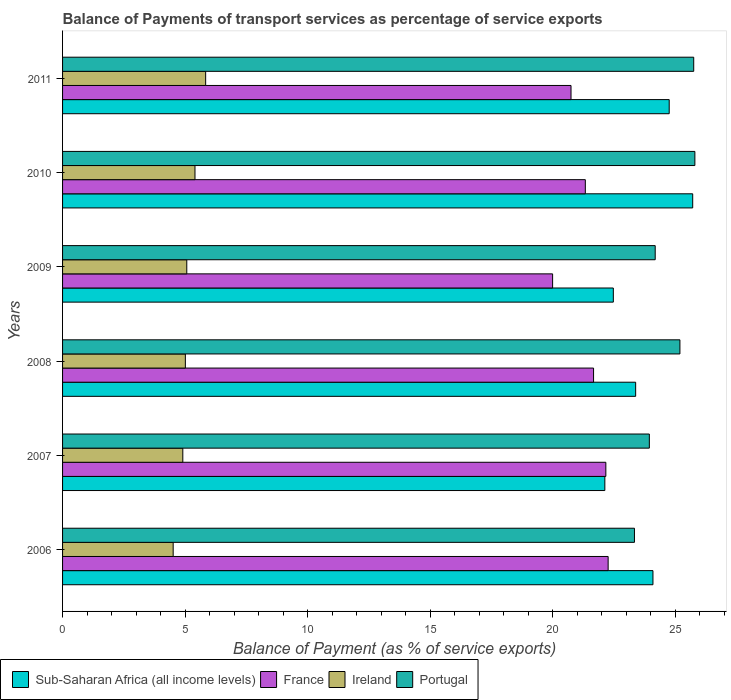How many groups of bars are there?
Keep it short and to the point. 6. Are the number of bars on each tick of the Y-axis equal?
Offer a very short reply. Yes. How many bars are there on the 3rd tick from the top?
Give a very brief answer. 4. How many bars are there on the 1st tick from the bottom?
Keep it short and to the point. 4. What is the label of the 6th group of bars from the top?
Provide a short and direct response. 2006. In how many cases, is the number of bars for a given year not equal to the number of legend labels?
Your answer should be compact. 0. What is the balance of payments of transport services in France in 2006?
Offer a terse response. 22.27. Across all years, what is the maximum balance of payments of transport services in Ireland?
Ensure brevity in your answer.  5.84. Across all years, what is the minimum balance of payments of transport services in France?
Provide a short and direct response. 20. In which year was the balance of payments of transport services in Portugal minimum?
Provide a short and direct response. 2006. What is the total balance of payments of transport services in Portugal in the graph?
Provide a short and direct response. 148.26. What is the difference between the balance of payments of transport services in Ireland in 2007 and that in 2010?
Offer a very short reply. -0.5. What is the difference between the balance of payments of transport services in Sub-Saharan Africa (all income levels) in 2011 and the balance of payments of transport services in Portugal in 2007?
Provide a succinct answer. 0.81. What is the average balance of payments of transport services in Portugal per year?
Ensure brevity in your answer.  24.71. In the year 2007, what is the difference between the balance of payments of transport services in Ireland and balance of payments of transport services in France?
Provide a short and direct response. -17.27. In how many years, is the balance of payments of transport services in Sub-Saharan Africa (all income levels) greater than 1 %?
Give a very brief answer. 6. What is the ratio of the balance of payments of transport services in Sub-Saharan Africa (all income levels) in 2006 to that in 2009?
Your answer should be very brief. 1.07. Is the balance of payments of transport services in Portugal in 2006 less than that in 2011?
Provide a short and direct response. Yes. Is the difference between the balance of payments of transport services in Ireland in 2006 and 2010 greater than the difference between the balance of payments of transport services in France in 2006 and 2010?
Ensure brevity in your answer.  No. What is the difference between the highest and the second highest balance of payments of transport services in Ireland?
Offer a terse response. 0.44. What is the difference between the highest and the lowest balance of payments of transport services in Portugal?
Keep it short and to the point. 2.47. What does the 1st bar from the bottom in 2007 represents?
Provide a succinct answer. Sub-Saharan Africa (all income levels). How many bars are there?
Offer a very short reply. 24. Are all the bars in the graph horizontal?
Offer a very short reply. Yes. What is the difference between two consecutive major ticks on the X-axis?
Your answer should be compact. 5. Are the values on the major ticks of X-axis written in scientific E-notation?
Your answer should be very brief. No. Does the graph contain any zero values?
Keep it short and to the point. No. Does the graph contain grids?
Provide a short and direct response. No. Where does the legend appear in the graph?
Keep it short and to the point. Bottom left. How are the legend labels stacked?
Offer a terse response. Horizontal. What is the title of the graph?
Provide a succinct answer. Balance of Payments of transport services as percentage of service exports. What is the label or title of the X-axis?
Your answer should be compact. Balance of Payment (as % of service exports). What is the label or title of the Y-axis?
Keep it short and to the point. Years. What is the Balance of Payment (as % of service exports) of Sub-Saharan Africa (all income levels) in 2006?
Provide a succinct answer. 24.1. What is the Balance of Payment (as % of service exports) in France in 2006?
Provide a succinct answer. 22.27. What is the Balance of Payment (as % of service exports) of Ireland in 2006?
Offer a very short reply. 4.52. What is the Balance of Payment (as % of service exports) of Portugal in 2006?
Your answer should be very brief. 23.34. What is the Balance of Payment (as % of service exports) of Sub-Saharan Africa (all income levels) in 2007?
Your answer should be very brief. 22.14. What is the Balance of Payment (as % of service exports) in France in 2007?
Offer a terse response. 22.18. What is the Balance of Payment (as % of service exports) in Ireland in 2007?
Your answer should be very brief. 4.91. What is the Balance of Payment (as % of service exports) of Portugal in 2007?
Offer a terse response. 23.95. What is the Balance of Payment (as % of service exports) of Sub-Saharan Africa (all income levels) in 2008?
Your answer should be compact. 23.39. What is the Balance of Payment (as % of service exports) in France in 2008?
Provide a short and direct response. 21.67. What is the Balance of Payment (as % of service exports) of Ireland in 2008?
Keep it short and to the point. 5.01. What is the Balance of Payment (as % of service exports) in Portugal in 2008?
Keep it short and to the point. 25.2. What is the Balance of Payment (as % of service exports) in Sub-Saharan Africa (all income levels) in 2009?
Offer a terse response. 22.48. What is the Balance of Payment (as % of service exports) in France in 2009?
Make the answer very short. 20. What is the Balance of Payment (as % of service exports) of Ireland in 2009?
Give a very brief answer. 5.07. What is the Balance of Payment (as % of service exports) of Portugal in 2009?
Provide a succinct answer. 24.19. What is the Balance of Payment (as % of service exports) in Sub-Saharan Africa (all income levels) in 2010?
Offer a very short reply. 25.72. What is the Balance of Payment (as % of service exports) in France in 2010?
Offer a terse response. 21.34. What is the Balance of Payment (as % of service exports) in Ireland in 2010?
Give a very brief answer. 5.4. What is the Balance of Payment (as % of service exports) of Portugal in 2010?
Your answer should be very brief. 25.81. What is the Balance of Payment (as % of service exports) in Sub-Saharan Africa (all income levels) in 2011?
Your response must be concise. 24.76. What is the Balance of Payment (as % of service exports) of France in 2011?
Keep it short and to the point. 20.75. What is the Balance of Payment (as % of service exports) in Ireland in 2011?
Ensure brevity in your answer.  5.84. What is the Balance of Payment (as % of service exports) in Portugal in 2011?
Ensure brevity in your answer.  25.76. Across all years, what is the maximum Balance of Payment (as % of service exports) in Sub-Saharan Africa (all income levels)?
Your answer should be compact. 25.72. Across all years, what is the maximum Balance of Payment (as % of service exports) in France?
Keep it short and to the point. 22.27. Across all years, what is the maximum Balance of Payment (as % of service exports) of Ireland?
Your answer should be very brief. 5.84. Across all years, what is the maximum Balance of Payment (as % of service exports) in Portugal?
Your response must be concise. 25.81. Across all years, what is the minimum Balance of Payment (as % of service exports) of Sub-Saharan Africa (all income levels)?
Your response must be concise. 22.14. Across all years, what is the minimum Balance of Payment (as % of service exports) of France?
Provide a short and direct response. 20. Across all years, what is the minimum Balance of Payment (as % of service exports) in Ireland?
Offer a terse response. 4.52. Across all years, what is the minimum Balance of Payment (as % of service exports) of Portugal?
Provide a short and direct response. 23.34. What is the total Balance of Payment (as % of service exports) in Sub-Saharan Africa (all income levels) in the graph?
Provide a short and direct response. 142.59. What is the total Balance of Payment (as % of service exports) of France in the graph?
Your response must be concise. 128.22. What is the total Balance of Payment (as % of service exports) of Ireland in the graph?
Provide a short and direct response. 30.75. What is the total Balance of Payment (as % of service exports) in Portugal in the graph?
Your answer should be very brief. 148.26. What is the difference between the Balance of Payment (as % of service exports) of Sub-Saharan Africa (all income levels) in 2006 and that in 2007?
Ensure brevity in your answer.  1.96. What is the difference between the Balance of Payment (as % of service exports) in France in 2006 and that in 2007?
Offer a very short reply. 0.09. What is the difference between the Balance of Payment (as % of service exports) in Ireland in 2006 and that in 2007?
Your response must be concise. -0.39. What is the difference between the Balance of Payment (as % of service exports) of Portugal in 2006 and that in 2007?
Offer a very short reply. -0.61. What is the difference between the Balance of Payment (as % of service exports) in Sub-Saharan Africa (all income levels) in 2006 and that in 2008?
Offer a very short reply. 0.71. What is the difference between the Balance of Payment (as % of service exports) of France in 2006 and that in 2008?
Offer a terse response. 0.6. What is the difference between the Balance of Payment (as % of service exports) in Ireland in 2006 and that in 2008?
Make the answer very short. -0.5. What is the difference between the Balance of Payment (as % of service exports) of Portugal in 2006 and that in 2008?
Give a very brief answer. -1.86. What is the difference between the Balance of Payment (as % of service exports) in Sub-Saharan Africa (all income levels) in 2006 and that in 2009?
Offer a terse response. 1.62. What is the difference between the Balance of Payment (as % of service exports) of France in 2006 and that in 2009?
Provide a succinct answer. 2.27. What is the difference between the Balance of Payment (as % of service exports) in Ireland in 2006 and that in 2009?
Ensure brevity in your answer.  -0.56. What is the difference between the Balance of Payment (as % of service exports) in Portugal in 2006 and that in 2009?
Your response must be concise. -0.85. What is the difference between the Balance of Payment (as % of service exports) of Sub-Saharan Africa (all income levels) in 2006 and that in 2010?
Keep it short and to the point. -1.62. What is the difference between the Balance of Payment (as % of service exports) in France in 2006 and that in 2010?
Your answer should be very brief. 0.93. What is the difference between the Balance of Payment (as % of service exports) of Ireland in 2006 and that in 2010?
Your answer should be very brief. -0.89. What is the difference between the Balance of Payment (as % of service exports) in Portugal in 2006 and that in 2010?
Keep it short and to the point. -2.47. What is the difference between the Balance of Payment (as % of service exports) of Sub-Saharan Africa (all income levels) in 2006 and that in 2011?
Ensure brevity in your answer.  -0.66. What is the difference between the Balance of Payment (as % of service exports) of France in 2006 and that in 2011?
Offer a terse response. 1.52. What is the difference between the Balance of Payment (as % of service exports) of Ireland in 2006 and that in 2011?
Offer a terse response. -1.33. What is the difference between the Balance of Payment (as % of service exports) in Portugal in 2006 and that in 2011?
Make the answer very short. -2.42. What is the difference between the Balance of Payment (as % of service exports) of Sub-Saharan Africa (all income levels) in 2007 and that in 2008?
Your response must be concise. -1.26. What is the difference between the Balance of Payment (as % of service exports) in France in 2007 and that in 2008?
Ensure brevity in your answer.  0.5. What is the difference between the Balance of Payment (as % of service exports) of Ireland in 2007 and that in 2008?
Provide a succinct answer. -0.1. What is the difference between the Balance of Payment (as % of service exports) of Portugal in 2007 and that in 2008?
Give a very brief answer. -1.25. What is the difference between the Balance of Payment (as % of service exports) in Sub-Saharan Africa (all income levels) in 2007 and that in 2009?
Offer a terse response. -0.35. What is the difference between the Balance of Payment (as % of service exports) of France in 2007 and that in 2009?
Your answer should be compact. 2.17. What is the difference between the Balance of Payment (as % of service exports) in Ireland in 2007 and that in 2009?
Provide a short and direct response. -0.16. What is the difference between the Balance of Payment (as % of service exports) in Portugal in 2007 and that in 2009?
Provide a short and direct response. -0.24. What is the difference between the Balance of Payment (as % of service exports) of Sub-Saharan Africa (all income levels) in 2007 and that in 2010?
Keep it short and to the point. -3.59. What is the difference between the Balance of Payment (as % of service exports) in France in 2007 and that in 2010?
Give a very brief answer. 0.84. What is the difference between the Balance of Payment (as % of service exports) of Ireland in 2007 and that in 2010?
Ensure brevity in your answer.  -0.5. What is the difference between the Balance of Payment (as % of service exports) in Portugal in 2007 and that in 2010?
Ensure brevity in your answer.  -1.86. What is the difference between the Balance of Payment (as % of service exports) in Sub-Saharan Africa (all income levels) in 2007 and that in 2011?
Offer a very short reply. -2.63. What is the difference between the Balance of Payment (as % of service exports) in France in 2007 and that in 2011?
Keep it short and to the point. 1.42. What is the difference between the Balance of Payment (as % of service exports) in Ireland in 2007 and that in 2011?
Your answer should be compact. -0.93. What is the difference between the Balance of Payment (as % of service exports) of Portugal in 2007 and that in 2011?
Provide a short and direct response. -1.81. What is the difference between the Balance of Payment (as % of service exports) of Sub-Saharan Africa (all income levels) in 2008 and that in 2009?
Provide a short and direct response. 0.91. What is the difference between the Balance of Payment (as % of service exports) of France in 2008 and that in 2009?
Offer a very short reply. 1.67. What is the difference between the Balance of Payment (as % of service exports) in Ireland in 2008 and that in 2009?
Offer a terse response. -0.06. What is the difference between the Balance of Payment (as % of service exports) in Portugal in 2008 and that in 2009?
Offer a very short reply. 1.01. What is the difference between the Balance of Payment (as % of service exports) of Sub-Saharan Africa (all income levels) in 2008 and that in 2010?
Keep it short and to the point. -2.33. What is the difference between the Balance of Payment (as % of service exports) of France in 2008 and that in 2010?
Your answer should be very brief. 0.34. What is the difference between the Balance of Payment (as % of service exports) of Ireland in 2008 and that in 2010?
Offer a terse response. -0.39. What is the difference between the Balance of Payment (as % of service exports) in Portugal in 2008 and that in 2010?
Your answer should be compact. -0.61. What is the difference between the Balance of Payment (as % of service exports) in Sub-Saharan Africa (all income levels) in 2008 and that in 2011?
Make the answer very short. -1.37. What is the difference between the Balance of Payment (as % of service exports) in France in 2008 and that in 2011?
Offer a very short reply. 0.92. What is the difference between the Balance of Payment (as % of service exports) of Ireland in 2008 and that in 2011?
Keep it short and to the point. -0.83. What is the difference between the Balance of Payment (as % of service exports) in Portugal in 2008 and that in 2011?
Provide a short and direct response. -0.56. What is the difference between the Balance of Payment (as % of service exports) of Sub-Saharan Africa (all income levels) in 2009 and that in 2010?
Your answer should be compact. -3.24. What is the difference between the Balance of Payment (as % of service exports) in France in 2009 and that in 2010?
Ensure brevity in your answer.  -1.34. What is the difference between the Balance of Payment (as % of service exports) of Ireland in 2009 and that in 2010?
Ensure brevity in your answer.  -0.33. What is the difference between the Balance of Payment (as % of service exports) of Portugal in 2009 and that in 2010?
Your answer should be compact. -1.62. What is the difference between the Balance of Payment (as % of service exports) in Sub-Saharan Africa (all income levels) in 2009 and that in 2011?
Provide a short and direct response. -2.28. What is the difference between the Balance of Payment (as % of service exports) in France in 2009 and that in 2011?
Your response must be concise. -0.75. What is the difference between the Balance of Payment (as % of service exports) of Ireland in 2009 and that in 2011?
Your answer should be very brief. -0.77. What is the difference between the Balance of Payment (as % of service exports) in Portugal in 2009 and that in 2011?
Keep it short and to the point. -1.57. What is the difference between the Balance of Payment (as % of service exports) in Sub-Saharan Africa (all income levels) in 2010 and that in 2011?
Offer a very short reply. 0.96. What is the difference between the Balance of Payment (as % of service exports) in France in 2010 and that in 2011?
Give a very brief answer. 0.58. What is the difference between the Balance of Payment (as % of service exports) in Ireland in 2010 and that in 2011?
Your answer should be compact. -0.44. What is the difference between the Balance of Payment (as % of service exports) of Portugal in 2010 and that in 2011?
Your answer should be very brief. 0.05. What is the difference between the Balance of Payment (as % of service exports) in Sub-Saharan Africa (all income levels) in 2006 and the Balance of Payment (as % of service exports) in France in 2007?
Provide a succinct answer. 1.92. What is the difference between the Balance of Payment (as % of service exports) of Sub-Saharan Africa (all income levels) in 2006 and the Balance of Payment (as % of service exports) of Ireland in 2007?
Provide a succinct answer. 19.19. What is the difference between the Balance of Payment (as % of service exports) of Sub-Saharan Africa (all income levels) in 2006 and the Balance of Payment (as % of service exports) of Portugal in 2007?
Your answer should be compact. 0.15. What is the difference between the Balance of Payment (as % of service exports) of France in 2006 and the Balance of Payment (as % of service exports) of Ireland in 2007?
Offer a very short reply. 17.36. What is the difference between the Balance of Payment (as % of service exports) in France in 2006 and the Balance of Payment (as % of service exports) in Portugal in 2007?
Your response must be concise. -1.68. What is the difference between the Balance of Payment (as % of service exports) in Ireland in 2006 and the Balance of Payment (as % of service exports) in Portugal in 2007?
Your answer should be very brief. -19.44. What is the difference between the Balance of Payment (as % of service exports) of Sub-Saharan Africa (all income levels) in 2006 and the Balance of Payment (as % of service exports) of France in 2008?
Your answer should be very brief. 2.42. What is the difference between the Balance of Payment (as % of service exports) of Sub-Saharan Africa (all income levels) in 2006 and the Balance of Payment (as % of service exports) of Ireland in 2008?
Provide a short and direct response. 19.09. What is the difference between the Balance of Payment (as % of service exports) of Sub-Saharan Africa (all income levels) in 2006 and the Balance of Payment (as % of service exports) of Portugal in 2008?
Provide a succinct answer. -1.1. What is the difference between the Balance of Payment (as % of service exports) in France in 2006 and the Balance of Payment (as % of service exports) in Ireland in 2008?
Give a very brief answer. 17.26. What is the difference between the Balance of Payment (as % of service exports) in France in 2006 and the Balance of Payment (as % of service exports) in Portugal in 2008?
Make the answer very short. -2.93. What is the difference between the Balance of Payment (as % of service exports) in Ireland in 2006 and the Balance of Payment (as % of service exports) in Portugal in 2008?
Provide a short and direct response. -20.68. What is the difference between the Balance of Payment (as % of service exports) of Sub-Saharan Africa (all income levels) in 2006 and the Balance of Payment (as % of service exports) of France in 2009?
Your answer should be very brief. 4.1. What is the difference between the Balance of Payment (as % of service exports) of Sub-Saharan Africa (all income levels) in 2006 and the Balance of Payment (as % of service exports) of Ireland in 2009?
Offer a very short reply. 19.03. What is the difference between the Balance of Payment (as % of service exports) in Sub-Saharan Africa (all income levels) in 2006 and the Balance of Payment (as % of service exports) in Portugal in 2009?
Provide a short and direct response. -0.09. What is the difference between the Balance of Payment (as % of service exports) of France in 2006 and the Balance of Payment (as % of service exports) of Ireland in 2009?
Keep it short and to the point. 17.2. What is the difference between the Balance of Payment (as % of service exports) in France in 2006 and the Balance of Payment (as % of service exports) in Portugal in 2009?
Your answer should be very brief. -1.92. What is the difference between the Balance of Payment (as % of service exports) of Ireland in 2006 and the Balance of Payment (as % of service exports) of Portugal in 2009?
Keep it short and to the point. -19.68. What is the difference between the Balance of Payment (as % of service exports) in Sub-Saharan Africa (all income levels) in 2006 and the Balance of Payment (as % of service exports) in France in 2010?
Provide a succinct answer. 2.76. What is the difference between the Balance of Payment (as % of service exports) in Sub-Saharan Africa (all income levels) in 2006 and the Balance of Payment (as % of service exports) in Ireland in 2010?
Make the answer very short. 18.69. What is the difference between the Balance of Payment (as % of service exports) of Sub-Saharan Africa (all income levels) in 2006 and the Balance of Payment (as % of service exports) of Portugal in 2010?
Offer a very short reply. -1.71. What is the difference between the Balance of Payment (as % of service exports) in France in 2006 and the Balance of Payment (as % of service exports) in Ireland in 2010?
Keep it short and to the point. 16.87. What is the difference between the Balance of Payment (as % of service exports) of France in 2006 and the Balance of Payment (as % of service exports) of Portugal in 2010?
Make the answer very short. -3.54. What is the difference between the Balance of Payment (as % of service exports) of Ireland in 2006 and the Balance of Payment (as % of service exports) of Portugal in 2010?
Your answer should be very brief. -21.3. What is the difference between the Balance of Payment (as % of service exports) of Sub-Saharan Africa (all income levels) in 2006 and the Balance of Payment (as % of service exports) of France in 2011?
Your response must be concise. 3.34. What is the difference between the Balance of Payment (as % of service exports) of Sub-Saharan Africa (all income levels) in 2006 and the Balance of Payment (as % of service exports) of Ireland in 2011?
Your answer should be very brief. 18.26. What is the difference between the Balance of Payment (as % of service exports) of Sub-Saharan Africa (all income levels) in 2006 and the Balance of Payment (as % of service exports) of Portugal in 2011?
Give a very brief answer. -1.66. What is the difference between the Balance of Payment (as % of service exports) in France in 2006 and the Balance of Payment (as % of service exports) in Ireland in 2011?
Your response must be concise. 16.43. What is the difference between the Balance of Payment (as % of service exports) of France in 2006 and the Balance of Payment (as % of service exports) of Portugal in 2011?
Give a very brief answer. -3.49. What is the difference between the Balance of Payment (as % of service exports) of Ireland in 2006 and the Balance of Payment (as % of service exports) of Portugal in 2011?
Keep it short and to the point. -21.25. What is the difference between the Balance of Payment (as % of service exports) of Sub-Saharan Africa (all income levels) in 2007 and the Balance of Payment (as % of service exports) of France in 2008?
Offer a terse response. 0.46. What is the difference between the Balance of Payment (as % of service exports) in Sub-Saharan Africa (all income levels) in 2007 and the Balance of Payment (as % of service exports) in Ireland in 2008?
Ensure brevity in your answer.  17.12. What is the difference between the Balance of Payment (as % of service exports) of Sub-Saharan Africa (all income levels) in 2007 and the Balance of Payment (as % of service exports) of Portugal in 2008?
Your answer should be compact. -3.06. What is the difference between the Balance of Payment (as % of service exports) in France in 2007 and the Balance of Payment (as % of service exports) in Ireland in 2008?
Make the answer very short. 17.16. What is the difference between the Balance of Payment (as % of service exports) in France in 2007 and the Balance of Payment (as % of service exports) in Portugal in 2008?
Make the answer very short. -3.02. What is the difference between the Balance of Payment (as % of service exports) of Ireland in 2007 and the Balance of Payment (as % of service exports) of Portugal in 2008?
Your response must be concise. -20.29. What is the difference between the Balance of Payment (as % of service exports) of Sub-Saharan Africa (all income levels) in 2007 and the Balance of Payment (as % of service exports) of France in 2009?
Your response must be concise. 2.13. What is the difference between the Balance of Payment (as % of service exports) in Sub-Saharan Africa (all income levels) in 2007 and the Balance of Payment (as % of service exports) in Ireland in 2009?
Ensure brevity in your answer.  17.07. What is the difference between the Balance of Payment (as % of service exports) of Sub-Saharan Africa (all income levels) in 2007 and the Balance of Payment (as % of service exports) of Portugal in 2009?
Your response must be concise. -2.06. What is the difference between the Balance of Payment (as % of service exports) in France in 2007 and the Balance of Payment (as % of service exports) in Ireland in 2009?
Provide a succinct answer. 17.11. What is the difference between the Balance of Payment (as % of service exports) in France in 2007 and the Balance of Payment (as % of service exports) in Portugal in 2009?
Your answer should be compact. -2.02. What is the difference between the Balance of Payment (as % of service exports) of Ireland in 2007 and the Balance of Payment (as % of service exports) of Portugal in 2009?
Provide a succinct answer. -19.28. What is the difference between the Balance of Payment (as % of service exports) of Sub-Saharan Africa (all income levels) in 2007 and the Balance of Payment (as % of service exports) of France in 2010?
Offer a very short reply. 0.8. What is the difference between the Balance of Payment (as % of service exports) of Sub-Saharan Africa (all income levels) in 2007 and the Balance of Payment (as % of service exports) of Ireland in 2010?
Your response must be concise. 16.73. What is the difference between the Balance of Payment (as % of service exports) of Sub-Saharan Africa (all income levels) in 2007 and the Balance of Payment (as % of service exports) of Portugal in 2010?
Your response must be concise. -3.67. What is the difference between the Balance of Payment (as % of service exports) of France in 2007 and the Balance of Payment (as % of service exports) of Ireland in 2010?
Offer a terse response. 16.77. What is the difference between the Balance of Payment (as % of service exports) in France in 2007 and the Balance of Payment (as % of service exports) in Portugal in 2010?
Offer a very short reply. -3.63. What is the difference between the Balance of Payment (as % of service exports) in Ireland in 2007 and the Balance of Payment (as % of service exports) in Portugal in 2010?
Provide a succinct answer. -20.9. What is the difference between the Balance of Payment (as % of service exports) in Sub-Saharan Africa (all income levels) in 2007 and the Balance of Payment (as % of service exports) in France in 2011?
Ensure brevity in your answer.  1.38. What is the difference between the Balance of Payment (as % of service exports) of Sub-Saharan Africa (all income levels) in 2007 and the Balance of Payment (as % of service exports) of Ireland in 2011?
Ensure brevity in your answer.  16.29. What is the difference between the Balance of Payment (as % of service exports) of Sub-Saharan Africa (all income levels) in 2007 and the Balance of Payment (as % of service exports) of Portugal in 2011?
Your answer should be compact. -3.63. What is the difference between the Balance of Payment (as % of service exports) of France in 2007 and the Balance of Payment (as % of service exports) of Ireland in 2011?
Your answer should be very brief. 16.34. What is the difference between the Balance of Payment (as % of service exports) of France in 2007 and the Balance of Payment (as % of service exports) of Portugal in 2011?
Keep it short and to the point. -3.59. What is the difference between the Balance of Payment (as % of service exports) in Ireland in 2007 and the Balance of Payment (as % of service exports) in Portugal in 2011?
Offer a terse response. -20.85. What is the difference between the Balance of Payment (as % of service exports) in Sub-Saharan Africa (all income levels) in 2008 and the Balance of Payment (as % of service exports) in France in 2009?
Offer a terse response. 3.39. What is the difference between the Balance of Payment (as % of service exports) of Sub-Saharan Africa (all income levels) in 2008 and the Balance of Payment (as % of service exports) of Ireland in 2009?
Make the answer very short. 18.32. What is the difference between the Balance of Payment (as % of service exports) in Sub-Saharan Africa (all income levels) in 2008 and the Balance of Payment (as % of service exports) in Portugal in 2009?
Offer a terse response. -0.8. What is the difference between the Balance of Payment (as % of service exports) in France in 2008 and the Balance of Payment (as % of service exports) in Ireland in 2009?
Make the answer very short. 16.6. What is the difference between the Balance of Payment (as % of service exports) of France in 2008 and the Balance of Payment (as % of service exports) of Portugal in 2009?
Ensure brevity in your answer.  -2.52. What is the difference between the Balance of Payment (as % of service exports) in Ireland in 2008 and the Balance of Payment (as % of service exports) in Portugal in 2009?
Your answer should be compact. -19.18. What is the difference between the Balance of Payment (as % of service exports) in Sub-Saharan Africa (all income levels) in 2008 and the Balance of Payment (as % of service exports) in France in 2010?
Your response must be concise. 2.05. What is the difference between the Balance of Payment (as % of service exports) of Sub-Saharan Africa (all income levels) in 2008 and the Balance of Payment (as % of service exports) of Ireland in 2010?
Your answer should be compact. 17.99. What is the difference between the Balance of Payment (as % of service exports) in Sub-Saharan Africa (all income levels) in 2008 and the Balance of Payment (as % of service exports) in Portugal in 2010?
Offer a very short reply. -2.42. What is the difference between the Balance of Payment (as % of service exports) in France in 2008 and the Balance of Payment (as % of service exports) in Ireland in 2010?
Provide a succinct answer. 16.27. What is the difference between the Balance of Payment (as % of service exports) of France in 2008 and the Balance of Payment (as % of service exports) of Portugal in 2010?
Your response must be concise. -4.14. What is the difference between the Balance of Payment (as % of service exports) of Ireland in 2008 and the Balance of Payment (as % of service exports) of Portugal in 2010?
Your answer should be compact. -20.8. What is the difference between the Balance of Payment (as % of service exports) in Sub-Saharan Africa (all income levels) in 2008 and the Balance of Payment (as % of service exports) in France in 2011?
Your response must be concise. 2.64. What is the difference between the Balance of Payment (as % of service exports) of Sub-Saharan Africa (all income levels) in 2008 and the Balance of Payment (as % of service exports) of Ireland in 2011?
Your response must be concise. 17.55. What is the difference between the Balance of Payment (as % of service exports) of Sub-Saharan Africa (all income levels) in 2008 and the Balance of Payment (as % of service exports) of Portugal in 2011?
Your answer should be compact. -2.37. What is the difference between the Balance of Payment (as % of service exports) in France in 2008 and the Balance of Payment (as % of service exports) in Ireland in 2011?
Your response must be concise. 15.83. What is the difference between the Balance of Payment (as % of service exports) of France in 2008 and the Balance of Payment (as % of service exports) of Portugal in 2011?
Your answer should be compact. -4.09. What is the difference between the Balance of Payment (as % of service exports) in Ireland in 2008 and the Balance of Payment (as % of service exports) in Portugal in 2011?
Your answer should be very brief. -20.75. What is the difference between the Balance of Payment (as % of service exports) in Sub-Saharan Africa (all income levels) in 2009 and the Balance of Payment (as % of service exports) in France in 2010?
Offer a terse response. 1.14. What is the difference between the Balance of Payment (as % of service exports) in Sub-Saharan Africa (all income levels) in 2009 and the Balance of Payment (as % of service exports) in Ireland in 2010?
Keep it short and to the point. 17.08. What is the difference between the Balance of Payment (as % of service exports) of Sub-Saharan Africa (all income levels) in 2009 and the Balance of Payment (as % of service exports) of Portugal in 2010?
Your answer should be very brief. -3.33. What is the difference between the Balance of Payment (as % of service exports) of France in 2009 and the Balance of Payment (as % of service exports) of Ireland in 2010?
Offer a terse response. 14.6. What is the difference between the Balance of Payment (as % of service exports) of France in 2009 and the Balance of Payment (as % of service exports) of Portugal in 2010?
Provide a short and direct response. -5.81. What is the difference between the Balance of Payment (as % of service exports) of Ireland in 2009 and the Balance of Payment (as % of service exports) of Portugal in 2010?
Give a very brief answer. -20.74. What is the difference between the Balance of Payment (as % of service exports) of Sub-Saharan Africa (all income levels) in 2009 and the Balance of Payment (as % of service exports) of France in 2011?
Make the answer very short. 1.73. What is the difference between the Balance of Payment (as % of service exports) in Sub-Saharan Africa (all income levels) in 2009 and the Balance of Payment (as % of service exports) in Ireland in 2011?
Your answer should be very brief. 16.64. What is the difference between the Balance of Payment (as % of service exports) of Sub-Saharan Africa (all income levels) in 2009 and the Balance of Payment (as % of service exports) of Portugal in 2011?
Offer a terse response. -3.28. What is the difference between the Balance of Payment (as % of service exports) of France in 2009 and the Balance of Payment (as % of service exports) of Ireland in 2011?
Your response must be concise. 14.16. What is the difference between the Balance of Payment (as % of service exports) in France in 2009 and the Balance of Payment (as % of service exports) in Portugal in 2011?
Make the answer very short. -5.76. What is the difference between the Balance of Payment (as % of service exports) of Ireland in 2009 and the Balance of Payment (as % of service exports) of Portugal in 2011?
Make the answer very short. -20.69. What is the difference between the Balance of Payment (as % of service exports) of Sub-Saharan Africa (all income levels) in 2010 and the Balance of Payment (as % of service exports) of France in 2011?
Keep it short and to the point. 4.97. What is the difference between the Balance of Payment (as % of service exports) of Sub-Saharan Africa (all income levels) in 2010 and the Balance of Payment (as % of service exports) of Ireland in 2011?
Provide a short and direct response. 19.88. What is the difference between the Balance of Payment (as % of service exports) in Sub-Saharan Africa (all income levels) in 2010 and the Balance of Payment (as % of service exports) in Portugal in 2011?
Provide a short and direct response. -0.04. What is the difference between the Balance of Payment (as % of service exports) in France in 2010 and the Balance of Payment (as % of service exports) in Ireland in 2011?
Provide a short and direct response. 15.5. What is the difference between the Balance of Payment (as % of service exports) in France in 2010 and the Balance of Payment (as % of service exports) in Portugal in 2011?
Make the answer very short. -4.42. What is the difference between the Balance of Payment (as % of service exports) in Ireland in 2010 and the Balance of Payment (as % of service exports) in Portugal in 2011?
Give a very brief answer. -20.36. What is the average Balance of Payment (as % of service exports) in Sub-Saharan Africa (all income levels) per year?
Offer a terse response. 23.77. What is the average Balance of Payment (as % of service exports) of France per year?
Ensure brevity in your answer.  21.37. What is the average Balance of Payment (as % of service exports) in Ireland per year?
Provide a short and direct response. 5.13. What is the average Balance of Payment (as % of service exports) in Portugal per year?
Offer a very short reply. 24.71. In the year 2006, what is the difference between the Balance of Payment (as % of service exports) of Sub-Saharan Africa (all income levels) and Balance of Payment (as % of service exports) of France?
Your answer should be very brief. 1.83. In the year 2006, what is the difference between the Balance of Payment (as % of service exports) in Sub-Saharan Africa (all income levels) and Balance of Payment (as % of service exports) in Ireland?
Your answer should be compact. 19.58. In the year 2006, what is the difference between the Balance of Payment (as % of service exports) of Sub-Saharan Africa (all income levels) and Balance of Payment (as % of service exports) of Portugal?
Ensure brevity in your answer.  0.76. In the year 2006, what is the difference between the Balance of Payment (as % of service exports) in France and Balance of Payment (as % of service exports) in Ireland?
Offer a terse response. 17.75. In the year 2006, what is the difference between the Balance of Payment (as % of service exports) of France and Balance of Payment (as % of service exports) of Portugal?
Provide a succinct answer. -1.07. In the year 2006, what is the difference between the Balance of Payment (as % of service exports) of Ireland and Balance of Payment (as % of service exports) of Portugal?
Give a very brief answer. -18.83. In the year 2007, what is the difference between the Balance of Payment (as % of service exports) of Sub-Saharan Africa (all income levels) and Balance of Payment (as % of service exports) of France?
Provide a succinct answer. -0.04. In the year 2007, what is the difference between the Balance of Payment (as % of service exports) in Sub-Saharan Africa (all income levels) and Balance of Payment (as % of service exports) in Ireland?
Ensure brevity in your answer.  17.23. In the year 2007, what is the difference between the Balance of Payment (as % of service exports) in Sub-Saharan Africa (all income levels) and Balance of Payment (as % of service exports) in Portugal?
Provide a short and direct response. -1.82. In the year 2007, what is the difference between the Balance of Payment (as % of service exports) in France and Balance of Payment (as % of service exports) in Ireland?
Make the answer very short. 17.27. In the year 2007, what is the difference between the Balance of Payment (as % of service exports) of France and Balance of Payment (as % of service exports) of Portugal?
Provide a short and direct response. -1.78. In the year 2007, what is the difference between the Balance of Payment (as % of service exports) of Ireland and Balance of Payment (as % of service exports) of Portugal?
Ensure brevity in your answer.  -19.04. In the year 2008, what is the difference between the Balance of Payment (as % of service exports) of Sub-Saharan Africa (all income levels) and Balance of Payment (as % of service exports) of France?
Give a very brief answer. 1.72. In the year 2008, what is the difference between the Balance of Payment (as % of service exports) of Sub-Saharan Africa (all income levels) and Balance of Payment (as % of service exports) of Ireland?
Your answer should be very brief. 18.38. In the year 2008, what is the difference between the Balance of Payment (as % of service exports) of Sub-Saharan Africa (all income levels) and Balance of Payment (as % of service exports) of Portugal?
Ensure brevity in your answer.  -1.81. In the year 2008, what is the difference between the Balance of Payment (as % of service exports) in France and Balance of Payment (as % of service exports) in Ireland?
Offer a very short reply. 16.66. In the year 2008, what is the difference between the Balance of Payment (as % of service exports) in France and Balance of Payment (as % of service exports) in Portugal?
Ensure brevity in your answer.  -3.53. In the year 2008, what is the difference between the Balance of Payment (as % of service exports) of Ireland and Balance of Payment (as % of service exports) of Portugal?
Give a very brief answer. -20.19. In the year 2009, what is the difference between the Balance of Payment (as % of service exports) in Sub-Saharan Africa (all income levels) and Balance of Payment (as % of service exports) in France?
Make the answer very short. 2.48. In the year 2009, what is the difference between the Balance of Payment (as % of service exports) in Sub-Saharan Africa (all income levels) and Balance of Payment (as % of service exports) in Ireland?
Give a very brief answer. 17.41. In the year 2009, what is the difference between the Balance of Payment (as % of service exports) in Sub-Saharan Africa (all income levels) and Balance of Payment (as % of service exports) in Portugal?
Give a very brief answer. -1.71. In the year 2009, what is the difference between the Balance of Payment (as % of service exports) of France and Balance of Payment (as % of service exports) of Ireland?
Your answer should be very brief. 14.93. In the year 2009, what is the difference between the Balance of Payment (as % of service exports) in France and Balance of Payment (as % of service exports) in Portugal?
Your response must be concise. -4.19. In the year 2009, what is the difference between the Balance of Payment (as % of service exports) in Ireland and Balance of Payment (as % of service exports) in Portugal?
Offer a terse response. -19.12. In the year 2010, what is the difference between the Balance of Payment (as % of service exports) of Sub-Saharan Africa (all income levels) and Balance of Payment (as % of service exports) of France?
Make the answer very short. 4.38. In the year 2010, what is the difference between the Balance of Payment (as % of service exports) of Sub-Saharan Africa (all income levels) and Balance of Payment (as % of service exports) of Ireland?
Provide a short and direct response. 20.32. In the year 2010, what is the difference between the Balance of Payment (as % of service exports) of Sub-Saharan Africa (all income levels) and Balance of Payment (as % of service exports) of Portugal?
Your answer should be compact. -0.09. In the year 2010, what is the difference between the Balance of Payment (as % of service exports) of France and Balance of Payment (as % of service exports) of Ireland?
Your answer should be compact. 15.93. In the year 2010, what is the difference between the Balance of Payment (as % of service exports) of France and Balance of Payment (as % of service exports) of Portugal?
Provide a succinct answer. -4.47. In the year 2010, what is the difference between the Balance of Payment (as % of service exports) in Ireland and Balance of Payment (as % of service exports) in Portugal?
Your answer should be very brief. -20.41. In the year 2011, what is the difference between the Balance of Payment (as % of service exports) in Sub-Saharan Africa (all income levels) and Balance of Payment (as % of service exports) in France?
Give a very brief answer. 4.01. In the year 2011, what is the difference between the Balance of Payment (as % of service exports) in Sub-Saharan Africa (all income levels) and Balance of Payment (as % of service exports) in Ireland?
Provide a short and direct response. 18.92. In the year 2011, what is the difference between the Balance of Payment (as % of service exports) in Sub-Saharan Africa (all income levels) and Balance of Payment (as % of service exports) in Portugal?
Keep it short and to the point. -1. In the year 2011, what is the difference between the Balance of Payment (as % of service exports) of France and Balance of Payment (as % of service exports) of Ireland?
Provide a succinct answer. 14.91. In the year 2011, what is the difference between the Balance of Payment (as % of service exports) of France and Balance of Payment (as % of service exports) of Portugal?
Offer a terse response. -5.01. In the year 2011, what is the difference between the Balance of Payment (as % of service exports) in Ireland and Balance of Payment (as % of service exports) in Portugal?
Keep it short and to the point. -19.92. What is the ratio of the Balance of Payment (as % of service exports) of Sub-Saharan Africa (all income levels) in 2006 to that in 2007?
Provide a short and direct response. 1.09. What is the ratio of the Balance of Payment (as % of service exports) in France in 2006 to that in 2007?
Provide a succinct answer. 1. What is the ratio of the Balance of Payment (as % of service exports) in Ireland in 2006 to that in 2007?
Offer a very short reply. 0.92. What is the ratio of the Balance of Payment (as % of service exports) in Portugal in 2006 to that in 2007?
Offer a very short reply. 0.97. What is the ratio of the Balance of Payment (as % of service exports) of Sub-Saharan Africa (all income levels) in 2006 to that in 2008?
Your response must be concise. 1.03. What is the ratio of the Balance of Payment (as % of service exports) of France in 2006 to that in 2008?
Your response must be concise. 1.03. What is the ratio of the Balance of Payment (as % of service exports) of Ireland in 2006 to that in 2008?
Offer a terse response. 0.9. What is the ratio of the Balance of Payment (as % of service exports) of Portugal in 2006 to that in 2008?
Give a very brief answer. 0.93. What is the ratio of the Balance of Payment (as % of service exports) in Sub-Saharan Africa (all income levels) in 2006 to that in 2009?
Your answer should be very brief. 1.07. What is the ratio of the Balance of Payment (as % of service exports) in France in 2006 to that in 2009?
Your answer should be compact. 1.11. What is the ratio of the Balance of Payment (as % of service exports) of Ireland in 2006 to that in 2009?
Keep it short and to the point. 0.89. What is the ratio of the Balance of Payment (as % of service exports) of Sub-Saharan Africa (all income levels) in 2006 to that in 2010?
Keep it short and to the point. 0.94. What is the ratio of the Balance of Payment (as % of service exports) in France in 2006 to that in 2010?
Your response must be concise. 1.04. What is the ratio of the Balance of Payment (as % of service exports) of Ireland in 2006 to that in 2010?
Offer a very short reply. 0.84. What is the ratio of the Balance of Payment (as % of service exports) of Portugal in 2006 to that in 2010?
Offer a terse response. 0.9. What is the ratio of the Balance of Payment (as % of service exports) of Sub-Saharan Africa (all income levels) in 2006 to that in 2011?
Keep it short and to the point. 0.97. What is the ratio of the Balance of Payment (as % of service exports) in France in 2006 to that in 2011?
Make the answer very short. 1.07. What is the ratio of the Balance of Payment (as % of service exports) of Ireland in 2006 to that in 2011?
Your answer should be very brief. 0.77. What is the ratio of the Balance of Payment (as % of service exports) in Portugal in 2006 to that in 2011?
Provide a succinct answer. 0.91. What is the ratio of the Balance of Payment (as % of service exports) in Sub-Saharan Africa (all income levels) in 2007 to that in 2008?
Offer a very short reply. 0.95. What is the ratio of the Balance of Payment (as % of service exports) of France in 2007 to that in 2008?
Provide a short and direct response. 1.02. What is the ratio of the Balance of Payment (as % of service exports) of Ireland in 2007 to that in 2008?
Ensure brevity in your answer.  0.98. What is the ratio of the Balance of Payment (as % of service exports) in Portugal in 2007 to that in 2008?
Your answer should be compact. 0.95. What is the ratio of the Balance of Payment (as % of service exports) of Sub-Saharan Africa (all income levels) in 2007 to that in 2009?
Your response must be concise. 0.98. What is the ratio of the Balance of Payment (as % of service exports) of France in 2007 to that in 2009?
Ensure brevity in your answer.  1.11. What is the ratio of the Balance of Payment (as % of service exports) in Sub-Saharan Africa (all income levels) in 2007 to that in 2010?
Offer a terse response. 0.86. What is the ratio of the Balance of Payment (as % of service exports) in France in 2007 to that in 2010?
Your answer should be compact. 1.04. What is the ratio of the Balance of Payment (as % of service exports) in Ireland in 2007 to that in 2010?
Ensure brevity in your answer.  0.91. What is the ratio of the Balance of Payment (as % of service exports) in Portugal in 2007 to that in 2010?
Provide a succinct answer. 0.93. What is the ratio of the Balance of Payment (as % of service exports) of Sub-Saharan Africa (all income levels) in 2007 to that in 2011?
Keep it short and to the point. 0.89. What is the ratio of the Balance of Payment (as % of service exports) of France in 2007 to that in 2011?
Your response must be concise. 1.07. What is the ratio of the Balance of Payment (as % of service exports) in Ireland in 2007 to that in 2011?
Keep it short and to the point. 0.84. What is the ratio of the Balance of Payment (as % of service exports) of Portugal in 2007 to that in 2011?
Give a very brief answer. 0.93. What is the ratio of the Balance of Payment (as % of service exports) in Sub-Saharan Africa (all income levels) in 2008 to that in 2009?
Provide a short and direct response. 1.04. What is the ratio of the Balance of Payment (as % of service exports) of France in 2008 to that in 2009?
Keep it short and to the point. 1.08. What is the ratio of the Balance of Payment (as % of service exports) of Portugal in 2008 to that in 2009?
Offer a terse response. 1.04. What is the ratio of the Balance of Payment (as % of service exports) in Sub-Saharan Africa (all income levels) in 2008 to that in 2010?
Provide a succinct answer. 0.91. What is the ratio of the Balance of Payment (as % of service exports) in France in 2008 to that in 2010?
Your response must be concise. 1.02. What is the ratio of the Balance of Payment (as % of service exports) of Ireland in 2008 to that in 2010?
Offer a very short reply. 0.93. What is the ratio of the Balance of Payment (as % of service exports) in Portugal in 2008 to that in 2010?
Your response must be concise. 0.98. What is the ratio of the Balance of Payment (as % of service exports) in Sub-Saharan Africa (all income levels) in 2008 to that in 2011?
Provide a succinct answer. 0.94. What is the ratio of the Balance of Payment (as % of service exports) of France in 2008 to that in 2011?
Offer a terse response. 1.04. What is the ratio of the Balance of Payment (as % of service exports) of Ireland in 2008 to that in 2011?
Your answer should be compact. 0.86. What is the ratio of the Balance of Payment (as % of service exports) in Portugal in 2008 to that in 2011?
Make the answer very short. 0.98. What is the ratio of the Balance of Payment (as % of service exports) in Sub-Saharan Africa (all income levels) in 2009 to that in 2010?
Offer a very short reply. 0.87. What is the ratio of the Balance of Payment (as % of service exports) in France in 2009 to that in 2010?
Give a very brief answer. 0.94. What is the ratio of the Balance of Payment (as % of service exports) in Ireland in 2009 to that in 2010?
Provide a short and direct response. 0.94. What is the ratio of the Balance of Payment (as % of service exports) of Portugal in 2009 to that in 2010?
Make the answer very short. 0.94. What is the ratio of the Balance of Payment (as % of service exports) of Sub-Saharan Africa (all income levels) in 2009 to that in 2011?
Give a very brief answer. 0.91. What is the ratio of the Balance of Payment (as % of service exports) in France in 2009 to that in 2011?
Your answer should be compact. 0.96. What is the ratio of the Balance of Payment (as % of service exports) in Ireland in 2009 to that in 2011?
Keep it short and to the point. 0.87. What is the ratio of the Balance of Payment (as % of service exports) in Portugal in 2009 to that in 2011?
Give a very brief answer. 0.94. What is the ratio of the Balance of Payment (as % of service exports) in Sub-Saharan Africa (all income levels) in 2010 to that in 2011?
Give a very brief answer. 1.04. What is the ratio of the Balance of Payment (as % of service exports) in France in 2010 to that in 2011?
Ensure brevity in your answer.  1.03. What is the ratio of the Balance of Payment (as % of service exports) in Ireland in 2010 to that in 2011?
Your response must be concise. 0.93. What is the ratio of the Balance of Payment (as % of service exports) in Portugal in 2010 to that in 2011?
Offer a terse response. 1. What is the difference between the highest and the second highest Balance of Payment (as % of service exports) of Sub-Saharan Africa (all income levels)?
Keep it short and to the point. 0.96. What is the difference between the highest and the second highest Balance of Payment (as % of service exports) in France?
Provide a short and direct response. 0.09. What is the difference between the highest and the second highest Balance of Payment (as % of service exports) of Ireland?
Your answer should be very brief. 0.44. What is the difference between the highest and the second highest Balance of Payment (as % of service exports) in Portugal?
Ensure brevity in your answer.  0.05. What is the difference between the highest and the lowest Balance of Payment (as % of service exports) of Sub-Saharan Africa (all income levels)?
Give a very brief answer. 3.59. What is the difference between the highest and the lowest Balance of Payment (as % of service exports) in France?
Your answer should be compact. 2.27. What is the difference between the highest and the lowest Balance of Payment (as % of service exports) of Ireland?
Offer a terse response. 1.33. What is the difference between the highest and the lowest Balance of Payment (as % of service exports) of Portugal?
Offer a very short reply. 2.47. 